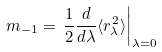<formula> <loc_0><loc_0><loc_500><loc_500>m _ { - 1 } = \left . \frac { 1 } { 2 } \frac { d } { d \lambda } \langle r ^ { 2 } _ { \lambda } \rangle \right | _ { \lambda = 0 }</formula> 